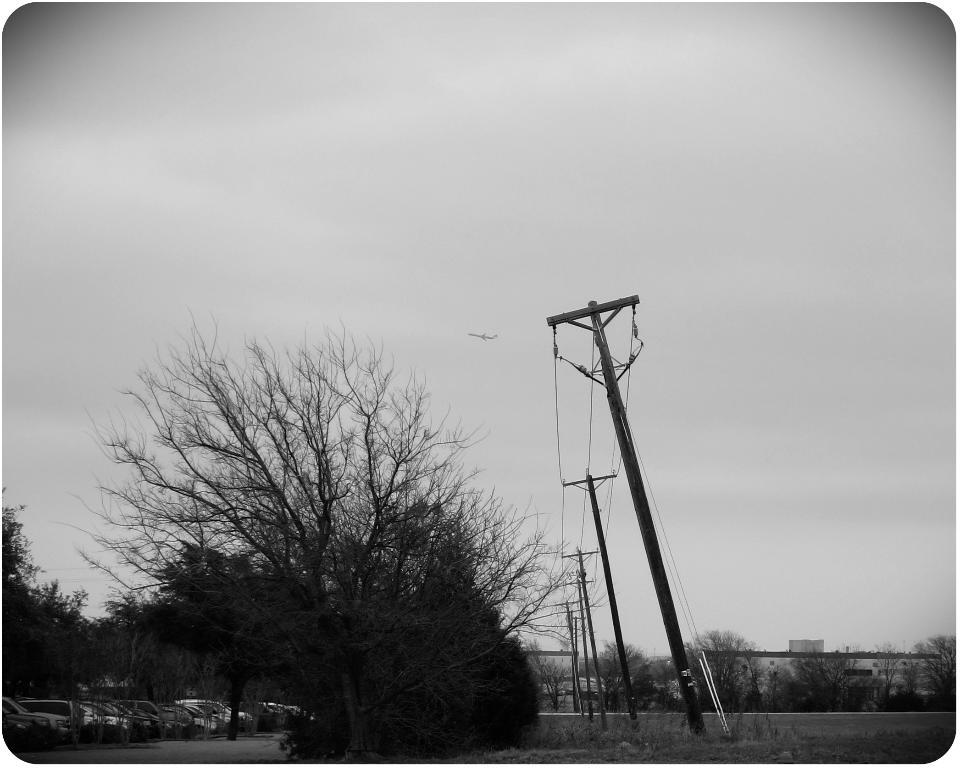What type of vehicles can be seen on the ground in the image? There are cars on the ground in the image. What natural elements are present in the image? There are trees in the image. What man-made structures can be seen in the image? There are poles and buildings in the image. What part of the natural environment is visible in the image? The sky is visible in the background of the image. Can you tell me how many plates are stacked on the bird in the image? There is no bird or plate present in the image. What type of fruit is the banana being used as in the image? There is no banana present in the image. 